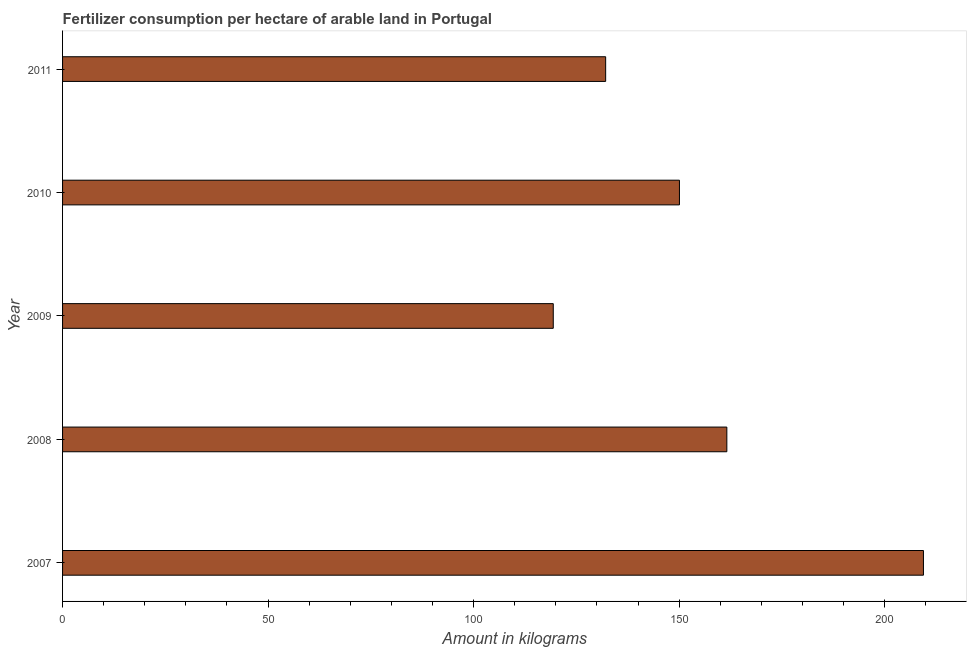Does the graph contain any zero values?
Ensure brevity in your answer.  No. Does the graph contain grids?
Give a very brief answer. No. What is the title of the graph?
Give a very brief answer. Fertilizer consumption per hectare of arable land in Portugal . What is the label or title of the X-axis?
Provide a short and direct response. Amount in kilograms. What is the label or title of the Y-axis?
Make the answer very short. Year. What is the amount of fertilizer consumption in 2011?
Your response must be concise. 132.13. Across all years, what is the maximum amount of fertilizer consumption?
Offer a terse response. 209.44. Across all years, what is the minimum amount of fertilizer consumption?
Provide a short and direct response. 119.38. In which year was the amount of fertilizer consumption maximum?
Your answer should be compact. 2007. In which year was the amount of fertilizer consumption minimum?
Your answer should be very brief. 2009. What is the sum of the amount of fertilizer consumption?
Give a very brief answer. 772.63. What is the difference between the amount of fertilizer consumption in 2007 and 2011?
Keep it short and to the point. 77.31. What is the average amount of fertilizer consumption per year?
Give a very brief answer. 154.53. What is the median amount of fertilizer consumption?
Provide a short and direct response. 150.08. In how many years, is the amount of fertilizer consumption greater than 50 kg?
Your response must be concise. 5. What is the ratio of the amount of fertilizer consumption in 2008 to that in 2009?
Ensure brevity in your answer.  1.35. Is the difference between the amount of fertilizer consumption in 2010 and 2011 greater than the difference between any two years?
Provide a succinct answer. No. What is the difference between the highest and the second highest amount of fertilizer consumption?
Ensure brevity in your answer.  47.83. Is the sum of the amount of fertilizer consumption in 2008 and 2010 greater than the maximum amount of fertilizer consumption across all years?
Your answer should be very brief. Yes. What is the difference between the highest and the lowest amount of fertilizer consumption?
Provide a short and direct response. 90.06. How many bars are there?
Give a very brief answer. 5. Are all the bars in the graph horizontal?
Your answer should be very brief. Yes. How many years are there in the graph?
Ensure brevity in your answer.  5. Are the values on the major ticks of X-axis written in scientific E-notation?
Provide a succinct answer. No. What is the Amount in kilograms in 2007?
Offer a terse response. 209.44. What is the Amount in kilograms in 2008?
Offer a very short reply. 161.61. What is the Amount in kilograms of 2009?
Offer a very short reply. 119.38. What is the Amount in kilograms of 2010?
Provide a succinct answer. 150.08. What is the Amount in kilograms in 2011?
Make the answer very short. 132.13. What is the difference between the Amount in kilograms in 2007 and 2008?
Give a very brief answer. 47.83. What is the difference between the Amount in kilograms in 2007 and 2009?
Give a very brief answer. 90.06. What is the difference between the Amount in kilograms in 2007 and 2010?
Your answer should be very brief. 59.36. What is the difference between the Amount in kilograms in 2007 and 2011?
Offer a very short reply. 77.31. What is the difference between the Amount in kilograms in 2008 and 2009?
Your answer should be very brief. 42.23. What is the difference between the Amount in kilograms in 2008 and 2010?
Your answer should be very brief. 11.53. What is the difference between the Amount in kilograms in 2008 and 2011?
Offer a terse response. 29.48. What is the difference between the Amount in kilograms in 2009 and 2010?
Keep it short and to the point. -30.7. What is the difference between the Amount in kilograms in 2009 and 2011?
Keep it short and to the point. -12.75. What is the difference between the Amount in kilograms in 2010 and 2011?
Make the answer very short. 17.95. What is the ratio of the Amount in kilograms in 2007 to that in 2008?
Provide a succinct answer. 1.3. What is the ratio of the Amount in kilograms in 2007 to that in 2009?
Offer a very short reply. 1.75. What is the ratio of the Amount in kilograms in 2007 to that in 2010?
Give a very brief answer. 1.4. What is the ratio of the Amount in kilograms in 2007 to that in 2011?
Your response must be concise. 1.58. What is the ratio of the Amount in kilograms in 2008 to that in 2009?
Offer a very short reply. 1.35. What is the ratio of the Amount in kilograms in 2008 to that in 2010?
Offer a very short reply. 1.08. What is the ratio of the Amount in kilograms in 2008 to that in 2011?
Your response must be concise. 1.22. What is the ratio of the Amount in kilograms in 2009 to that in 2010?
Offer a terse response. 0.8. What is the ratio of the Amount in kilograms in 2009 to that in 2011?
Make the answer very short. 0.9. What is the ratio of the Amount in kilograms in 2010 to that in 2011?
Keep it short and to the point. 1.14. 